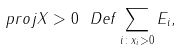Convert formula to latex. <formula><loc_0><loc_0><loc_500><loc_500>\ p r o j { X > 0 } \ D e f \sum _ { i \colon x _ { i } > 0 } E _ { i } ,</formula> 